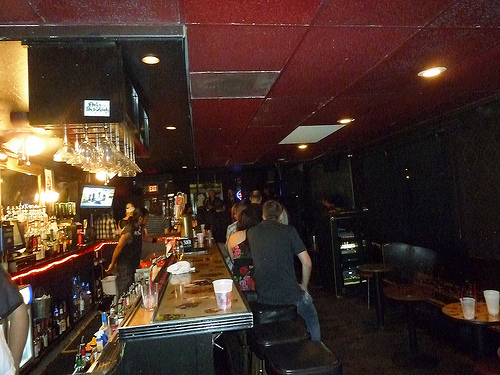<image>
Is there a beer in the glass? Yes. The beer is contained within or inside the glass, showing a containment relationship. Where is the tile in relation to the tile? Is it above the tile? No. The tile is not positioned above the tile. The vertical arrangement shows a different relationship. 